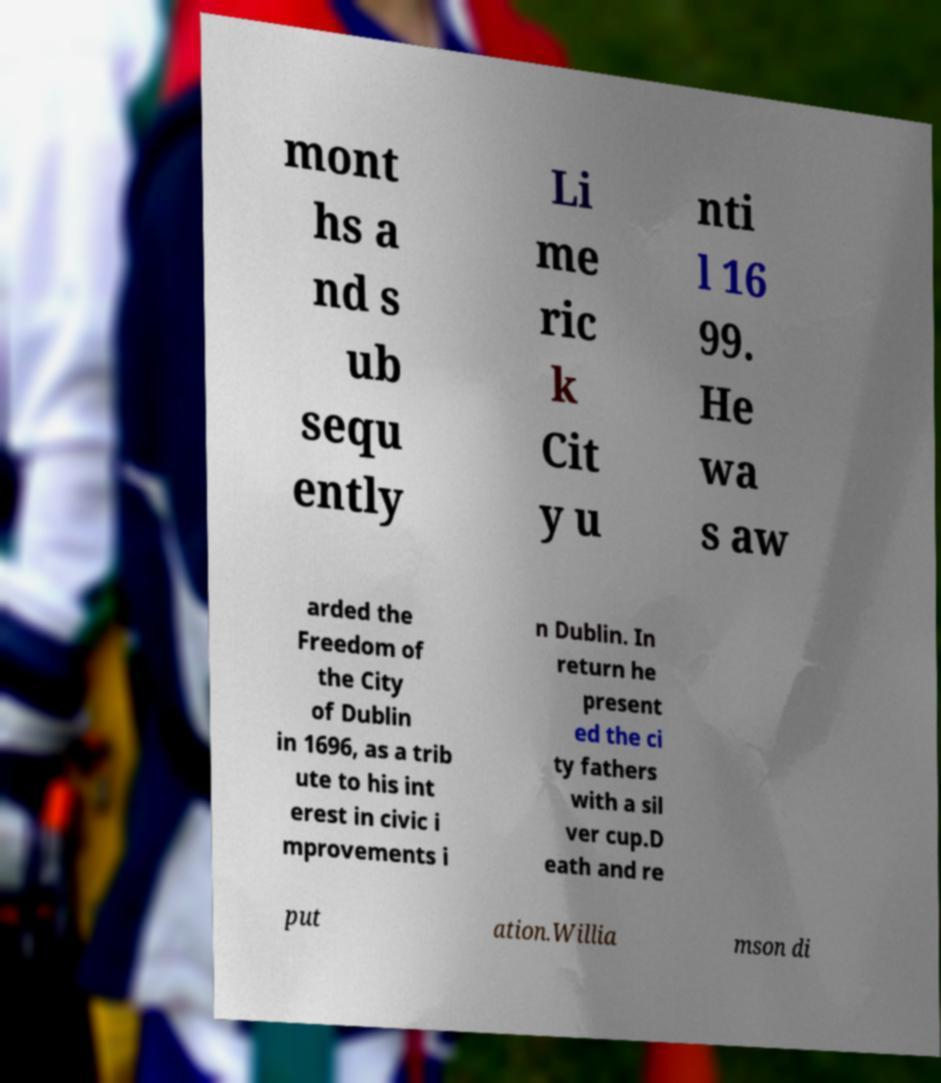Please identify and transcribe the text found in this image. mont hs a nd s ub sequ ently Li me ric k Cit y u nti l 16 99. He wa s aw arded the Freedom of the City of Dublin in 1696, as a trib ute to his int erest in civic i mprovements i n Dublin. In return he present ed the ci ty fathers with a sil ver cup.D eath and re put ation.Willia mson di 